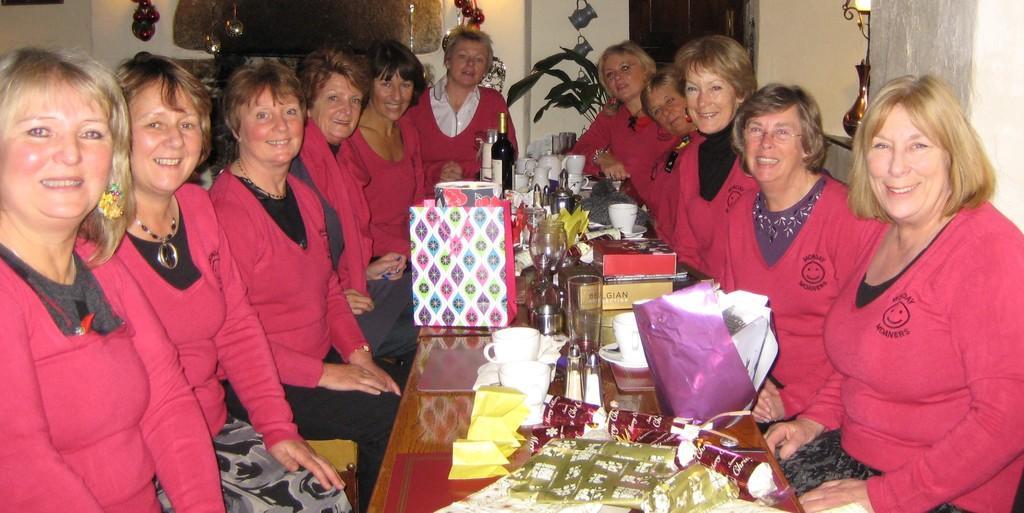Describe this image in one or two sentences. In the center of the image there is a table and we can see ladies sitting around the table. They are all wearing pink shirts. We can see glasses, bags, bottles, gifts and mugs placed on the table. In the background there is a wall and we can see wall decors placed on the wall. 